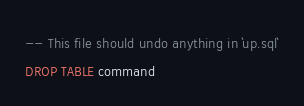<code> <loc_0><loc_0><loc_500><loc_500><_SQL_>-- This file should undo anything in `up.sql`
DROP TABLE command
</code> 